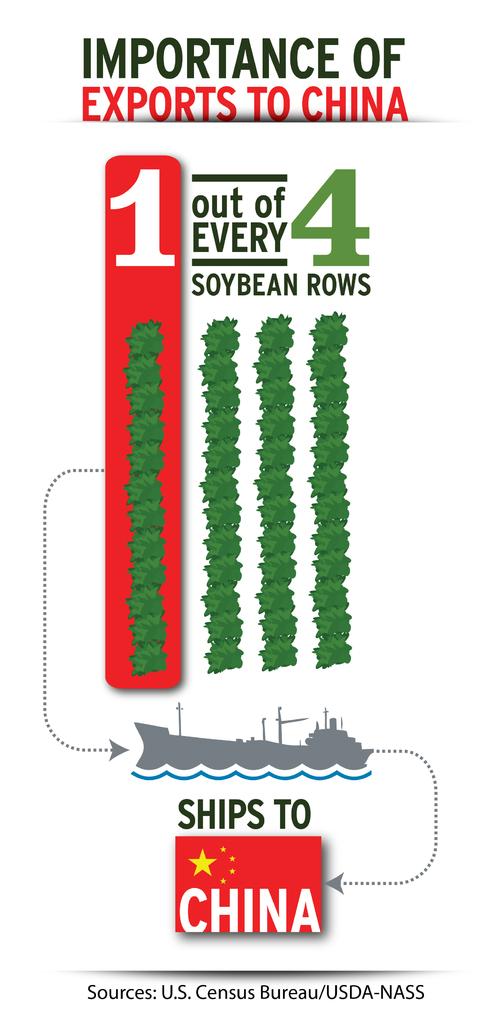Where do the exports ship to?
Offer a terse response. China. What percentage of soybeans get shipped to china?
Provide a short and direct response. 25%. 